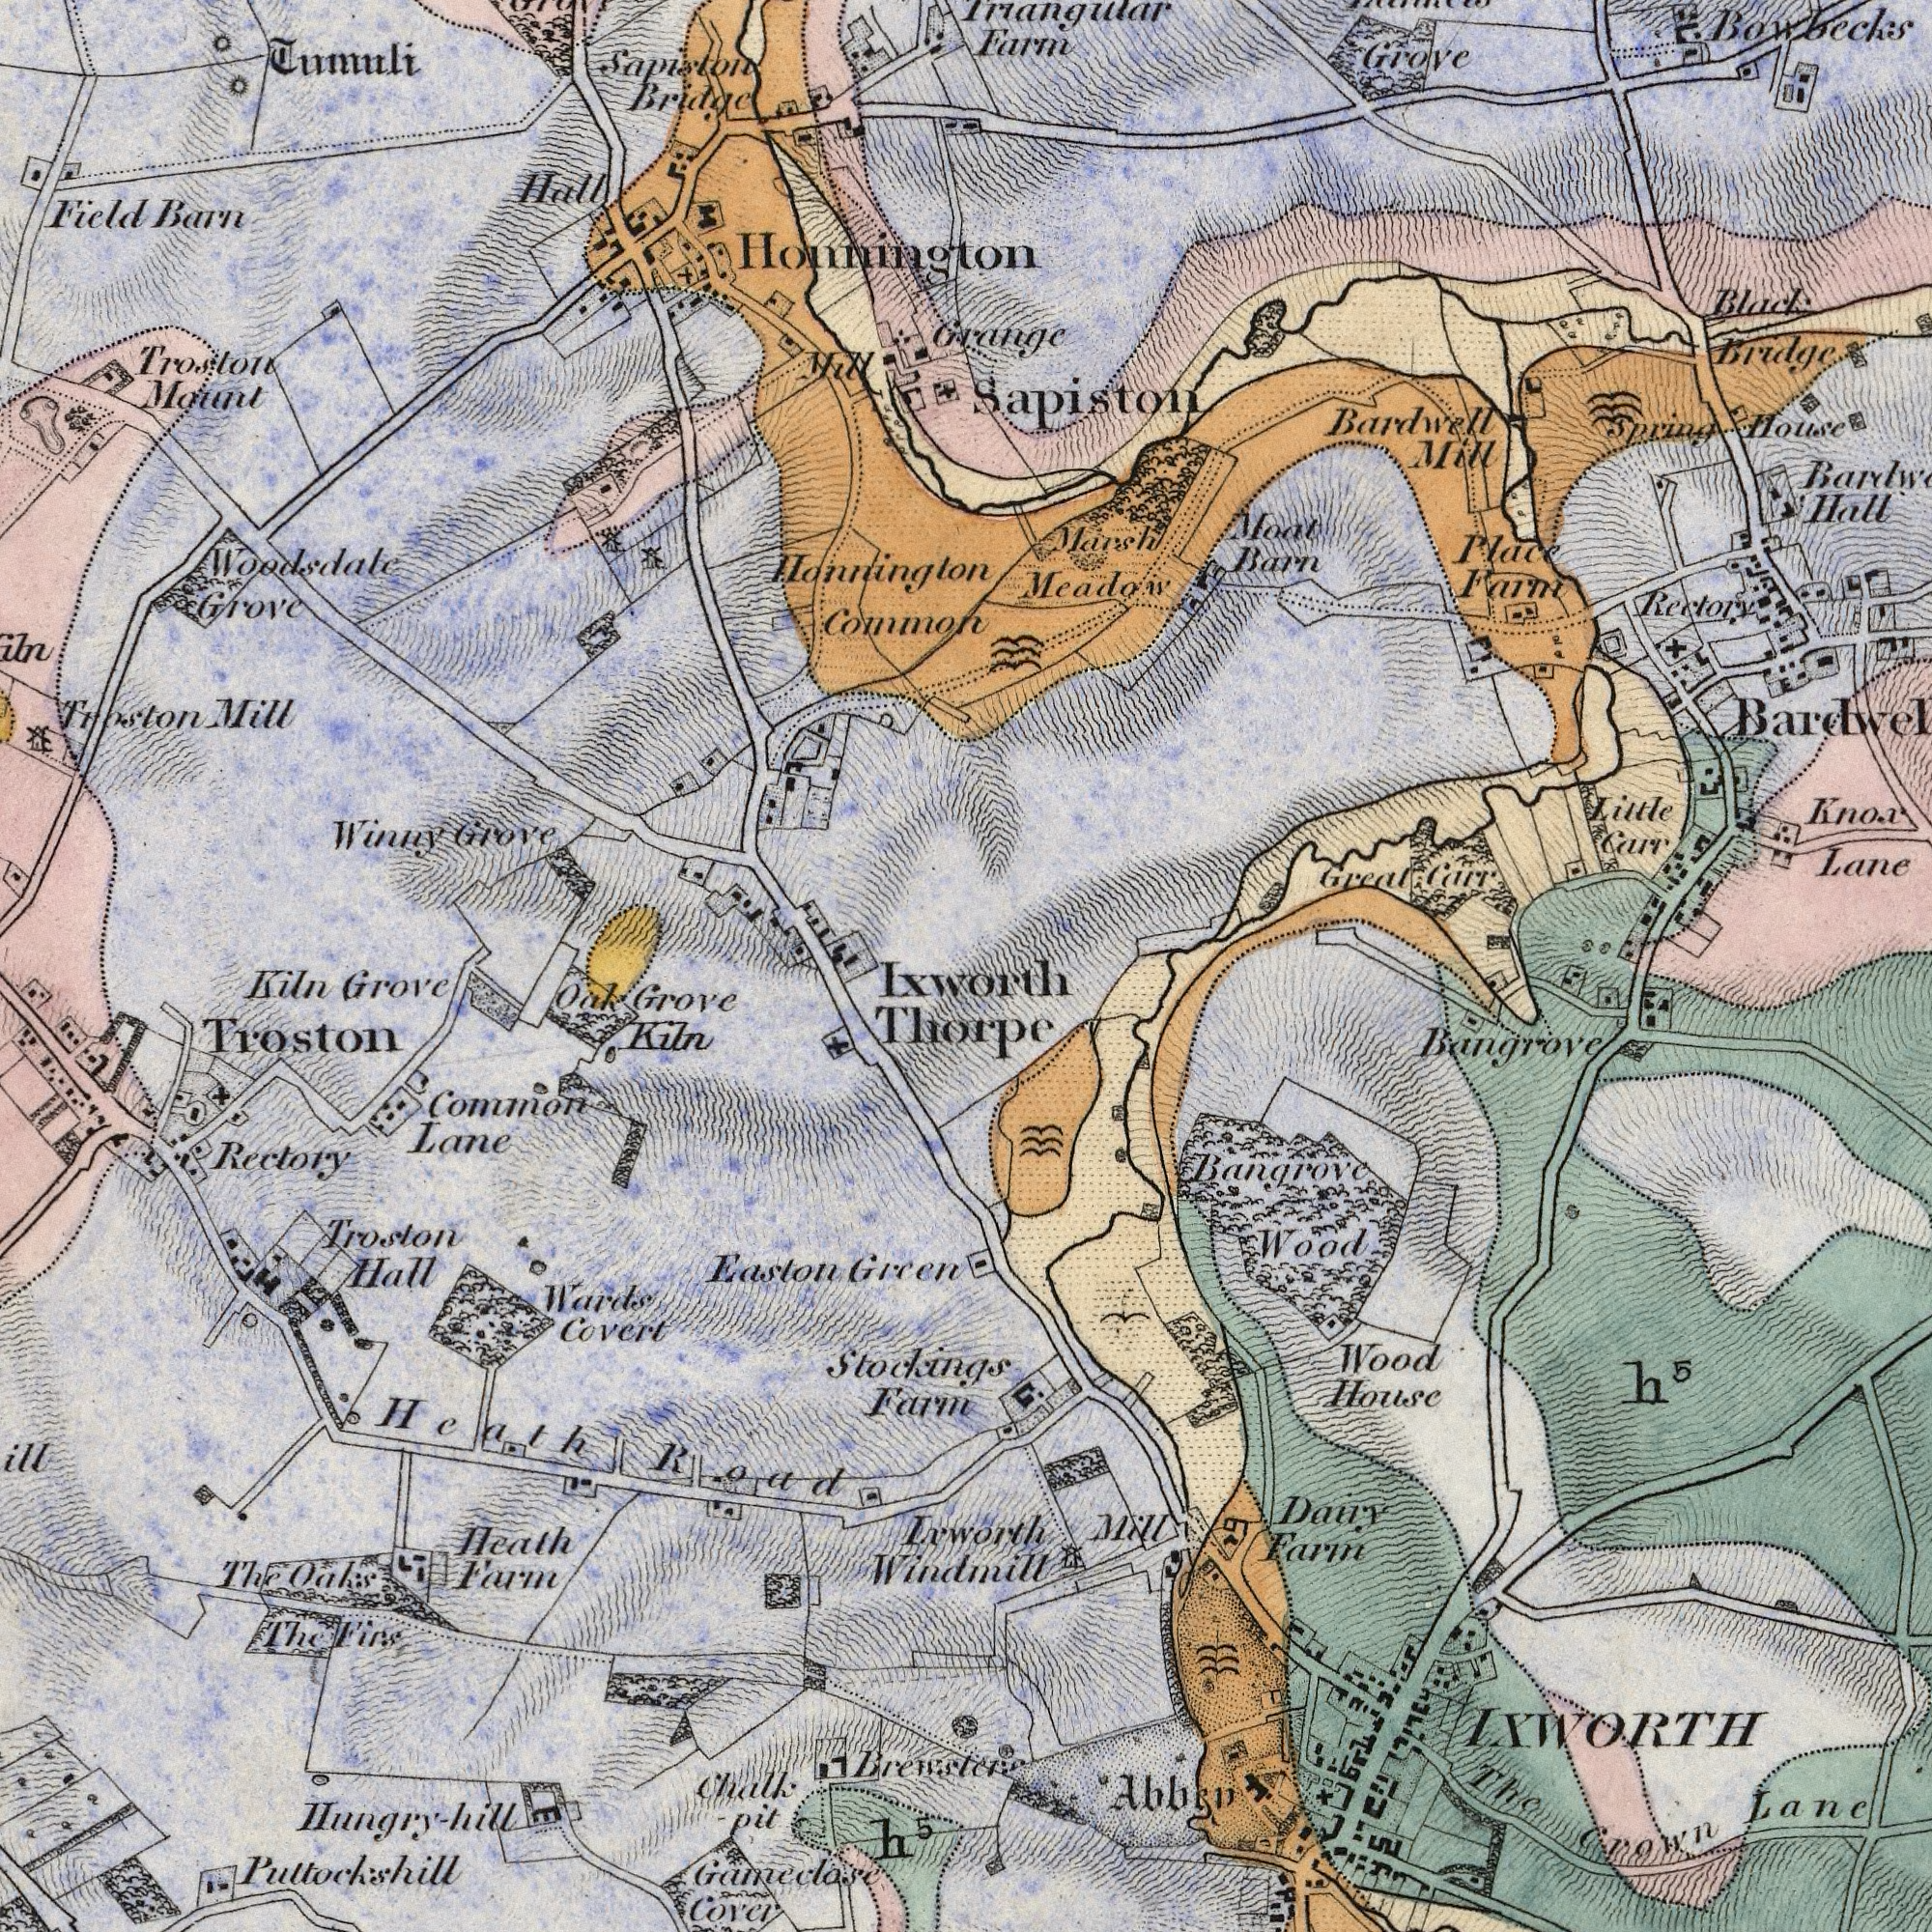What text is visible in the lower-right corner? Bangrove Crown Lane House Dairy Wood Mill LXWORTH Farm Wood Bangrove The Abbey h<sup>5</sup> What text can you see in the top-right section? Meadow Sapiston Bowbecks Bardwell Lane Little Farm Rectory Barn Hall Bridge Moat Marsh Grove Mill Farm Great Carr Place Black Carr House Spring Knox Grange What text appears in the bottom-left area of the image? Common Covert Troston Cover Heath Rectory Troston Grove Green Kiln Hall Easton Farm Kiln Oak Oaks Grove Firs Lane The The Farm Gameclase Heath Wards Ixworth Thorpe Stockings Road Inworth Windmill Hungry-hill Pultockshill Chalk -Pit h<sup>5</sup> Brewster What text is visible in the upper-left corner? Sapiston Grove Honnington Woodsdale Bridge Tumuli Troston Winny Common Hall Mill Field Mount Barn Honnington Grove Troston Mill 